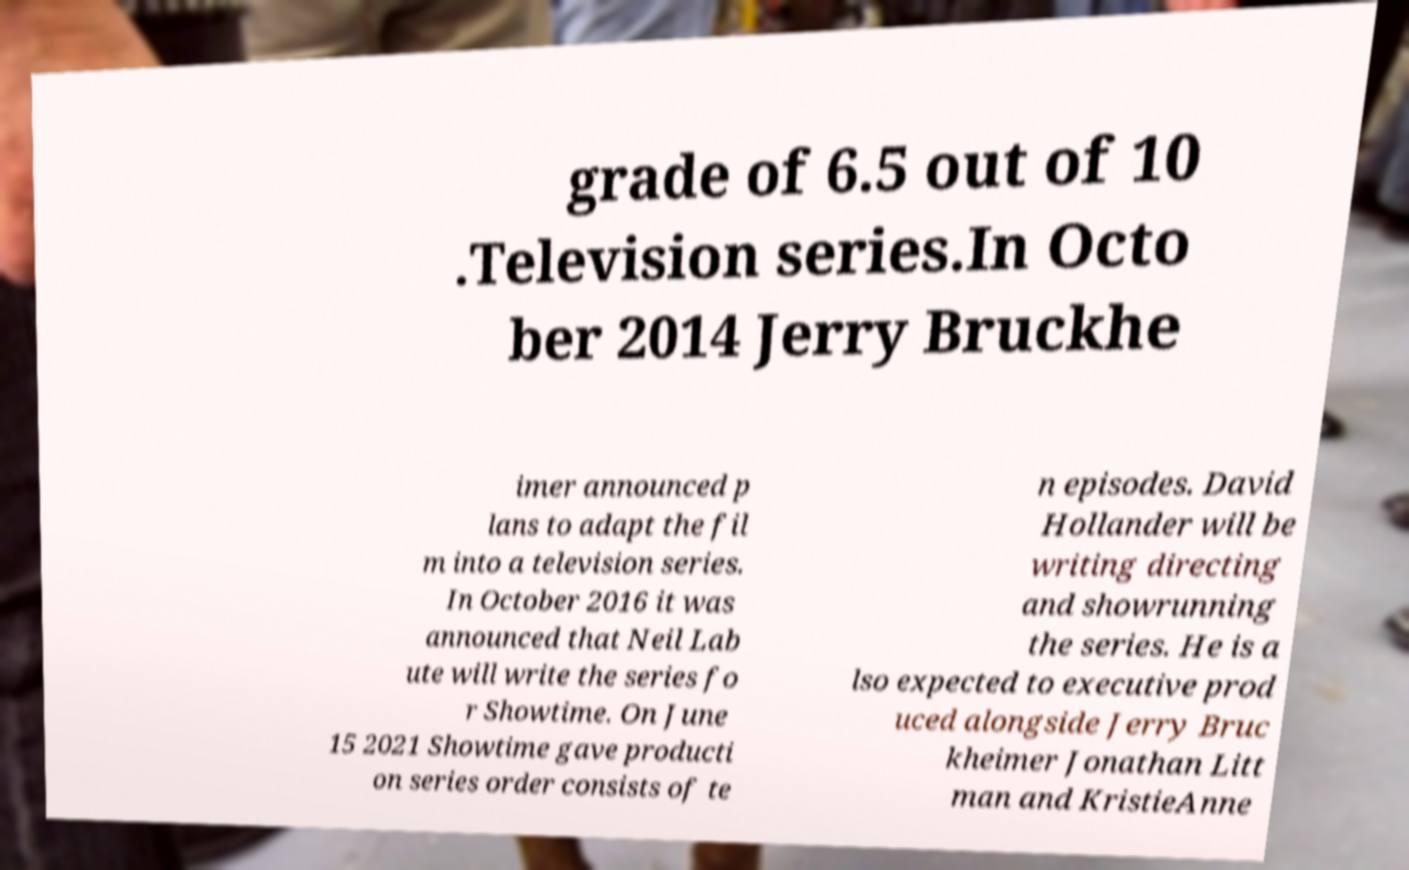Could you extract and type out the text from this image? grade of 6.5 out of 10 .Television series.In Octo ber 2014 Jerry Bruckhe imer announced p lans to adapt the fil m into a television series. In October 2016 it was announced that Neil Lab ute will write the series fo r Showtime. On June 15 2021 Showtime gave producti on series order consists of te n episodes. David Hollander will be writing directing and showrunning the series. He is a lso expected to executive prod uced alongside Jerry Bruc kheimer Jonathan Litt man and KristieAnne 